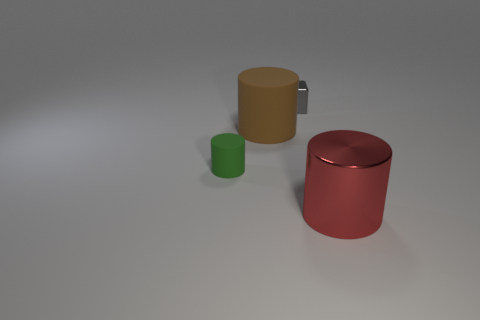Add 4 small rubber cylinders. How many objects exist? 8 Subtract all blocks. How many objects are left? 3 Subtract 0 yellow balls. How many objects are left? 4 Subtract all small yellow shiny cylinders. Subtract all tiny green cylinders. How many objects are left? 3 Add 3 big red shiny cylinders. How many big red shiny cylinders are left? 4 Add 4 large brown matte balls. How many large brown matte balls exist? 4 